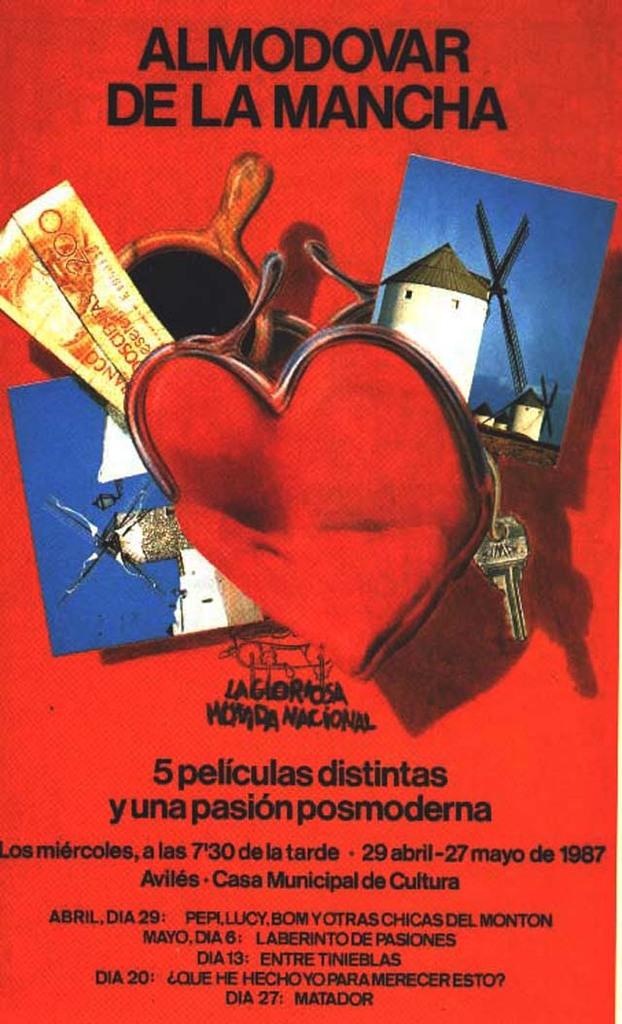What is the title of this poster?
Offer a very short reply. Almodovar de la mancha. What year did the events of the poster take place?
Your answer should be compact. 1987. 